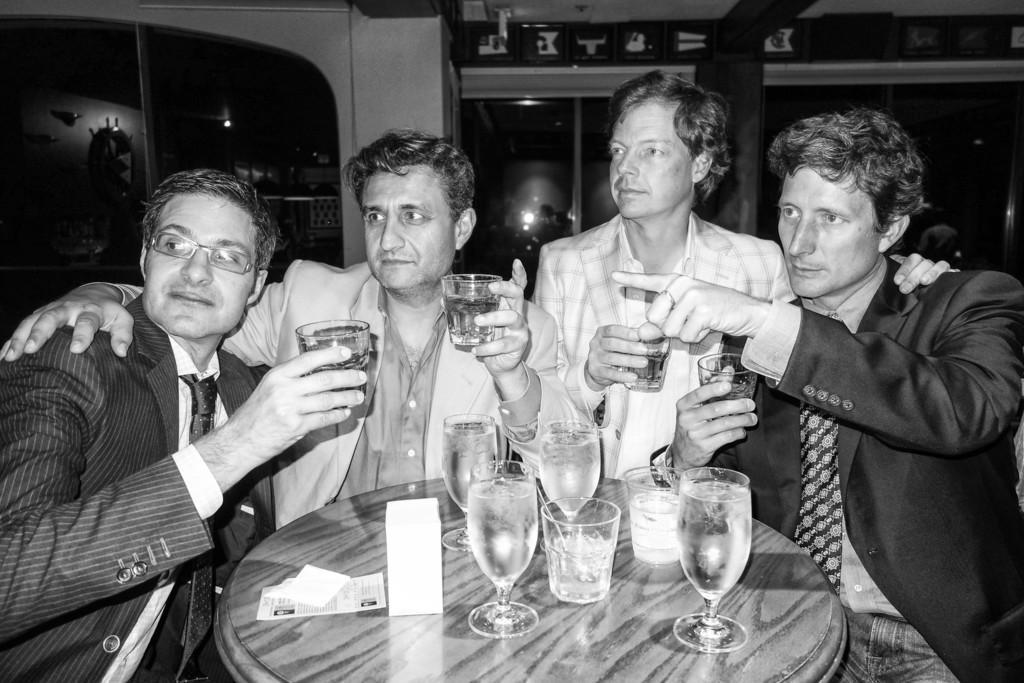Can you describe this image briefly? There are four persons holding a wine glass in their hands and there is a table in front of them which has a glass of wine on it. 